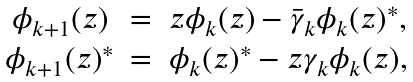Convert formula to latex. <formula><loc_0><loc_0><loc_500><loc_500>\begin{array} { c c c } \phi _ { k + 1 } ( z ) & = & z \phi _ { k } ( z ) - \bar { \gamma } _ { k } \phi _ { k } ( z ) ^ { * } , \\ \phi _ { k + 1 } ( z ) ^ { * } & = & \phi _ { k } ( z ) ^ { * } - z \gamma _ { k } \phi _ { k } ( z ) , \end{array}</formula> 